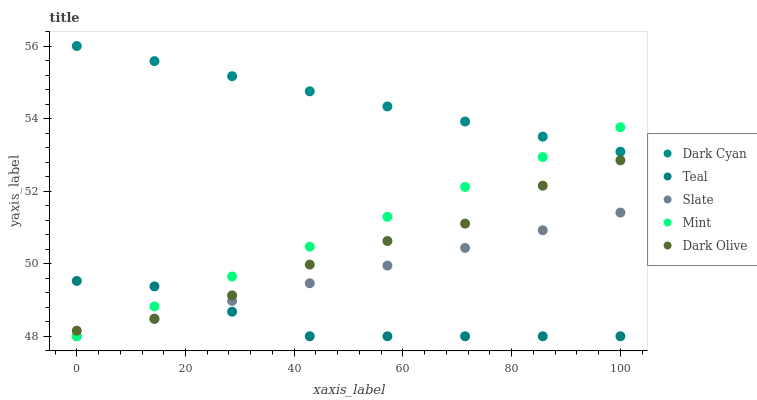Does Teal have the minimum area under the curve?
Answer yes or no. Yes. Does Dark Cyan have the maximum area under the curve?
Answer yes or no. Yes. Does Slate have the minimum area under the curve?
Answer yes or no. No. Does Slate have the maximum area under the curve?
Answer yes or no. No. Is Slate the smoothest?
Answer yes or no. Yes. Is Dark Olive the roughest?
Answer yes or no. Yes. Is Dark Olive the smoothest?
Answer yes or no. No. Is Slate the roughest?
Answer yes or no. No. Does Slate have the lowest value?
Answer yes or no. Yes. Does Dark Olive have the lowest value?
Answer yes or no. No. Does Dark Cyan have the highest value?
Answer yes or no. Yes. Does Slate have the highest value?
Answer yes or no. No. Is Teal less than Dark Cyan?
Answer yes or no. Yes. Is Dark Cyan greater than Slate?
Answer yes or no. Yes. Does Slate intersect Mint?
Answer yes or no. Yes. Is Slate less than Mint?
Answer yes or no. No. Is Slate greater than Mint?
Answer yes or no. No. Does Teal intersect Dark Cyan?
Answer yes or no. No. 